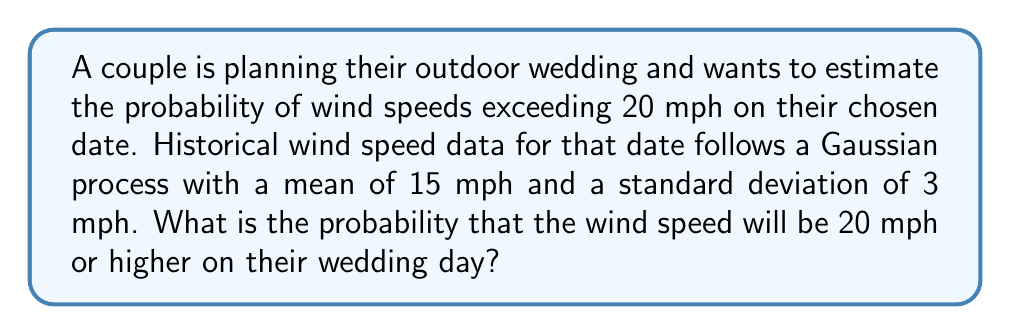Give your solution to this math problem. To solve this problem, we'll use the properties of the Gaussian (normal) distribution and the concept of standardization.

Step 1: Identify the given information
- Mean wind speed (μ) = 15 mph
- Standard deviation (σ) = 3 mph
- Threshold wind speed = 20 mph

Step 2: Standardize the threshold value
We need to calculate the z-score for the threshold wind speed:

$$ z = \frac{x - \mu}{\sigma} $$

Where x is the threshold value (20 mph).

$$ z = \frac{20 - 15}{3} = \frac{5}{3} \approx 1.67 $$

Step 3: Use the standard normal distribution
The probability we're looking for is the area under the standard normal curve to the right of z = 1.67.

$$ P(X \geq 20) = 1 - P(X < 20) = 1 - \Phi(1.67) $$

Where Φ(z) is the cumulative distribution function of the standard normal distribution.

Step 4: Look up the value in a standard normal table or use a calculator
Φ(1.67) ≈ 0.9525

Step 5: Calculate the final probability
$$ P(X \geq 20) = 1 - 0.9525 = 0.0475 $$

Therefore, the probability of wind speeds being 20 mph or higher on the wedding day is approximately 0.0475 or 4.75%.
Answer: 0.0475 (or 4.75%) 